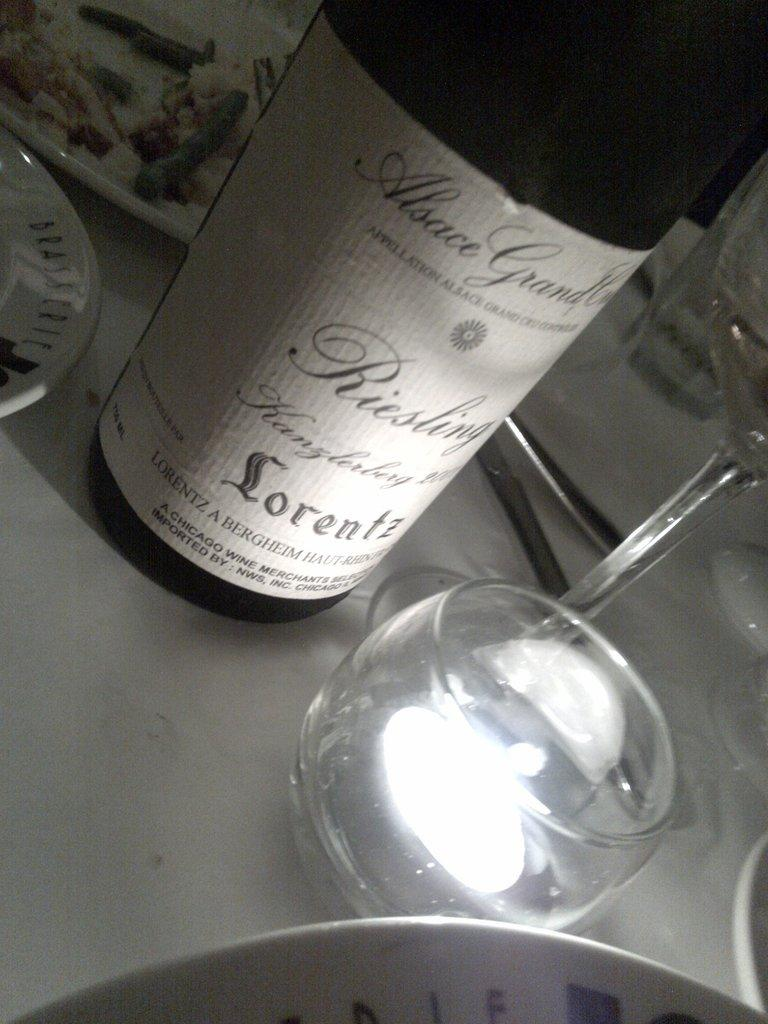<image>
Give a short and clear explanation of the subsequent image. Bottle of alcohol that says the word Lorentz on the bottom. 